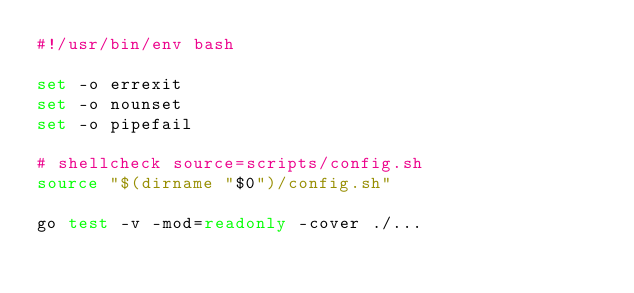Convert code to text. <code><loc_0><loc_0><loc_500><loc_500><_Bash_>#!/usr/bin/env bash

set -o errexit
set -o nounset
set -o pipefail

# shellcheck source=scripts/config.sh
source "$(dirname "$0")/config.sh"

go test -v -mod=readonly -cover ./...
</code> 